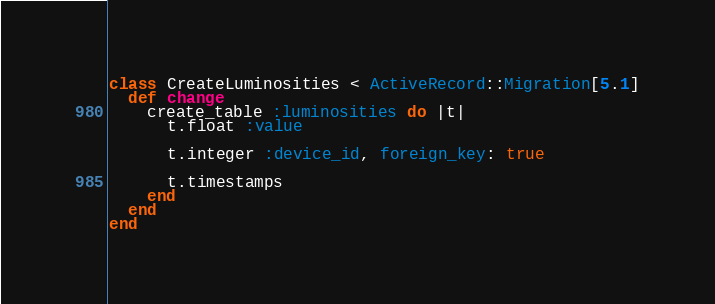Convert code to text. <code><loc_0><loc_0><loc_500><loc_500><_Ruby_>class CreateLuminosities < ActiveRecord::Migration[5.1]
  def change
    create_table :luminosities do |t|
      t.float :value
      
      t.integer :device_id, foreign_key: true

      t.timestamps
    end
  end
end
</code> 